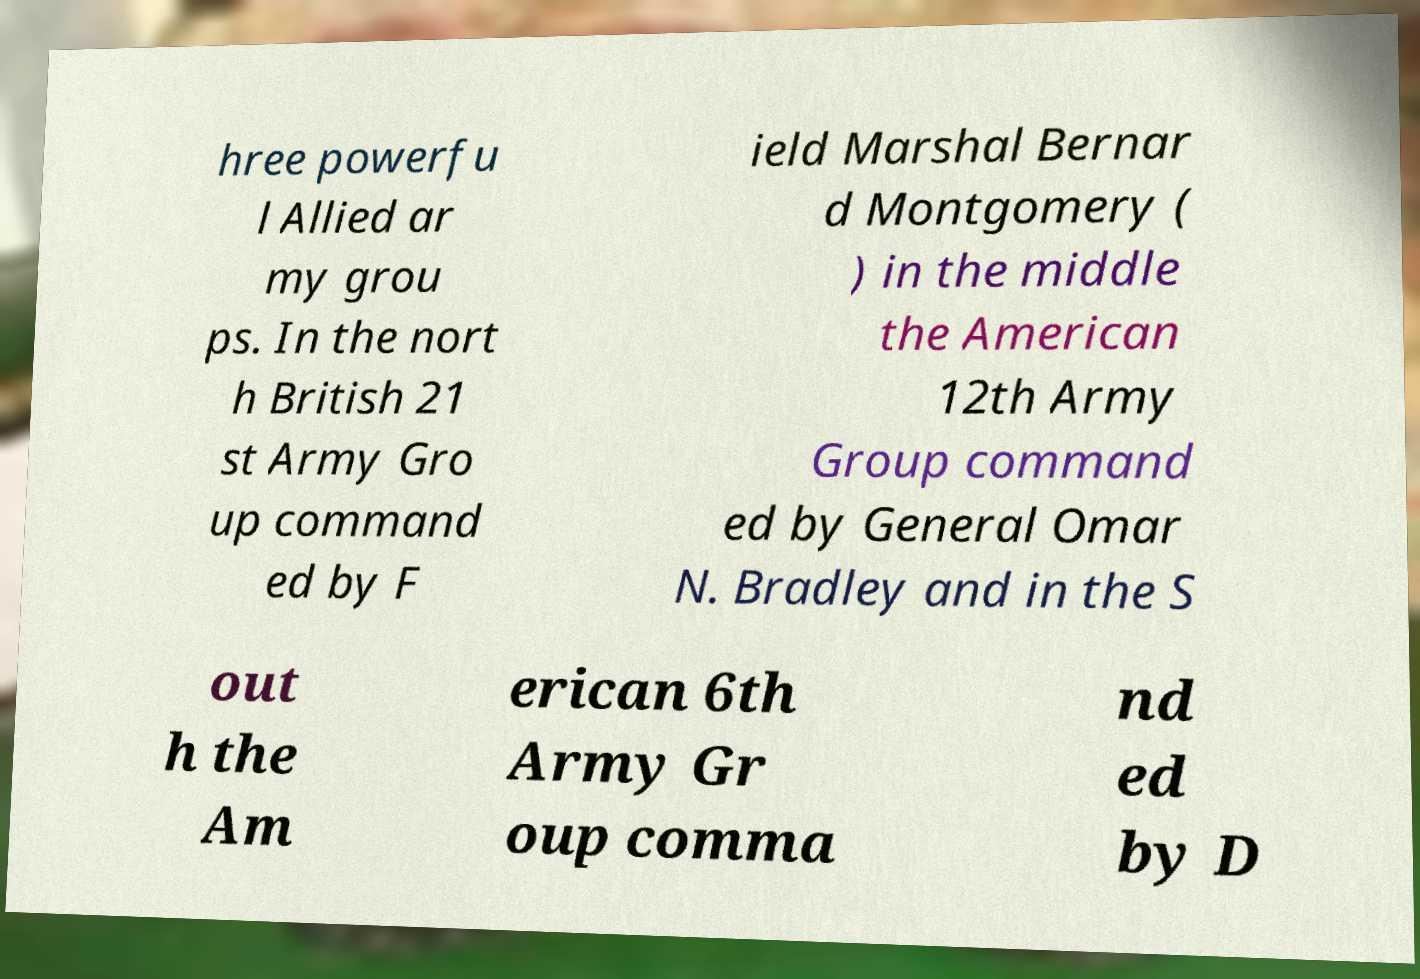Can you read and provide the text displayed in the image?This photo seems to have some interesting text. Can you extract and type it out for me? hree powerfu l Allied ar my grou ps. In the nort h British 21 st Army Gro up command ed by F ield Marshal Bernar d Montgomery ( ) in the middle the American 12th Army Group command ed by General Omar N. Bradley and in the S out h the Am erican 6th Army Gr oup comma nd ed by D 